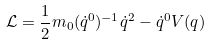<formula> <loc_0><loc_0><loc_500><loc_500>\mathcal { L } = \frac { 1 } { 2 } m _ { 0 } ( \dot { q } ^ { 0 } ) ^ { - 1 } \dot { q } ^ { 2 } - \dot { q } ^ { 0 } V ( q )</formula> 